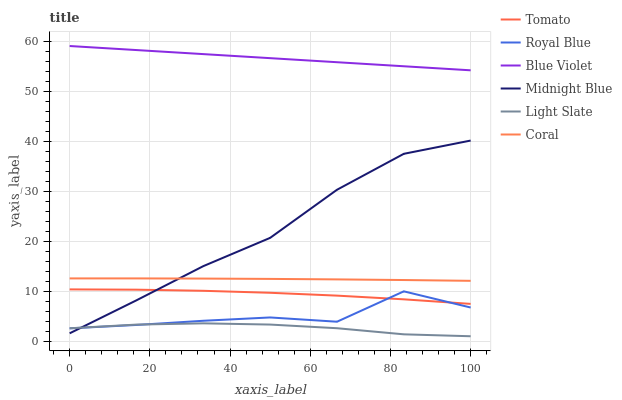Does Light Slate have the minimum area under the curve?
Answer yes or no. Yes. Does Blue Violet have the maximum area under the curve?
Answer yes or no. Yes. Does Midnight Blue have the minimum area under the curve?
Answer yes or no. No. Does Midnight Blue have the maximum area under the curve?
Answer yes or no. No. Is Blue Violet the smoothest?
Answer yes or no. Yes. Is Royal Blue the roughest?
Answer yes or no. Yes. Is Midnight Blue the smoothest?
Answer yes or no. No. Is Midnight Blue the roughest?
Answer yes or no. No. Does Light Slate have the lowest value?
Answer yes or no. Yes. Does Midnight Blue have the lowest value?
Answer yes or no. No. Does Blue Violet have the highest value?
Answer yes or no. Yes. Does Midnight Blue have the highest value?
Answer yes or no. No. Is Coral less than Blue Violet?
Answer yes or no. Yes. Is Blue Violet greater than Tomato?
Answer yes or no. Yes. Does Midnight Blue intersect Light Slate?
Answer yes or no. Yes. Is Midnight Blue less than Light Slate?
Answer yes or no. No. Is Midnight Blue greater than Light Slate?
Answer yes or no. No. Does Coral intersect Blue Violet?
Answer yes or no. No. 